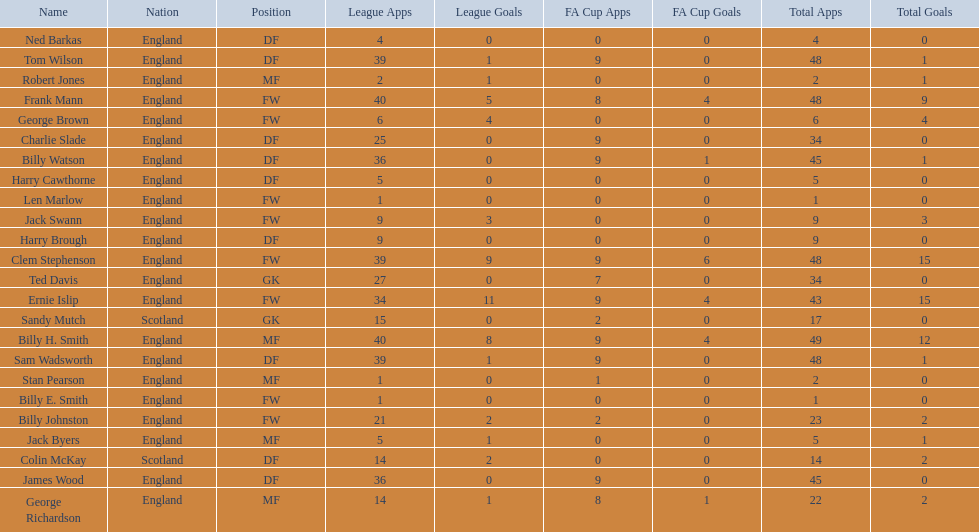Name the nation with the most appearances. England. 